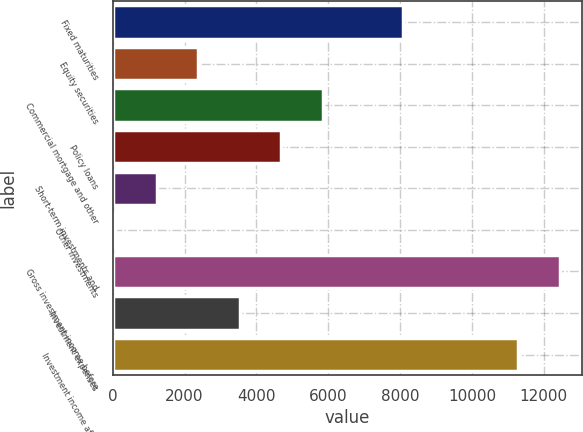<chart> <loc_0><loc_0><loc_500><loc_500><bar_chart><fcel>Fixed maturities<fcel>Equity securities<fcel>Commercial mortgage and other<fcel>Policy loans<fcel>Short-term investments and<fcel>Other investments<fcel>Gross investment income before<fcel>Investment expenses<fcel>Investment income after<nl><fcel>8073<fcel>2381.4<fcel>5854.5<fcel>4696.8<fcel>1223.7<fcel>66<fcel>12442.7<fcel>3539.1<fcel>11285<nl></chart> 